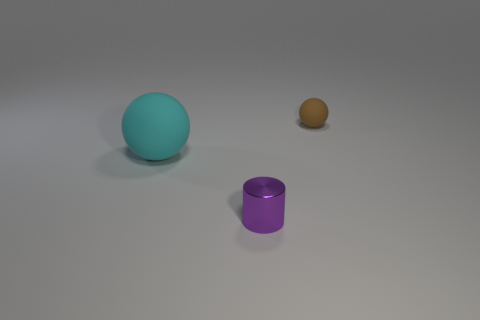Add 2 large red rubber objects. How many objects exist? 5 Subtract all cylinders. How many objects are left? 2 Subtract 1 cylinders. How many cylinders are left? 0 Subtract all tiny purple shiny things. Subtract all brown rubber spheres. How many objects are left? 1 Add 2 tiny purple metal things. How many tiny purple metal things are left? 3 Add 2 tiny brown rubber things. How many tiny brown rubber things exist? 3 Subtract 0 blue blocks. How many objects are left? 3 Subtract all gray balls. Subtract all blue blocks. How many balls are left? 2 Subtract all yellow cubes. How many yellow cylinders are left? 0 